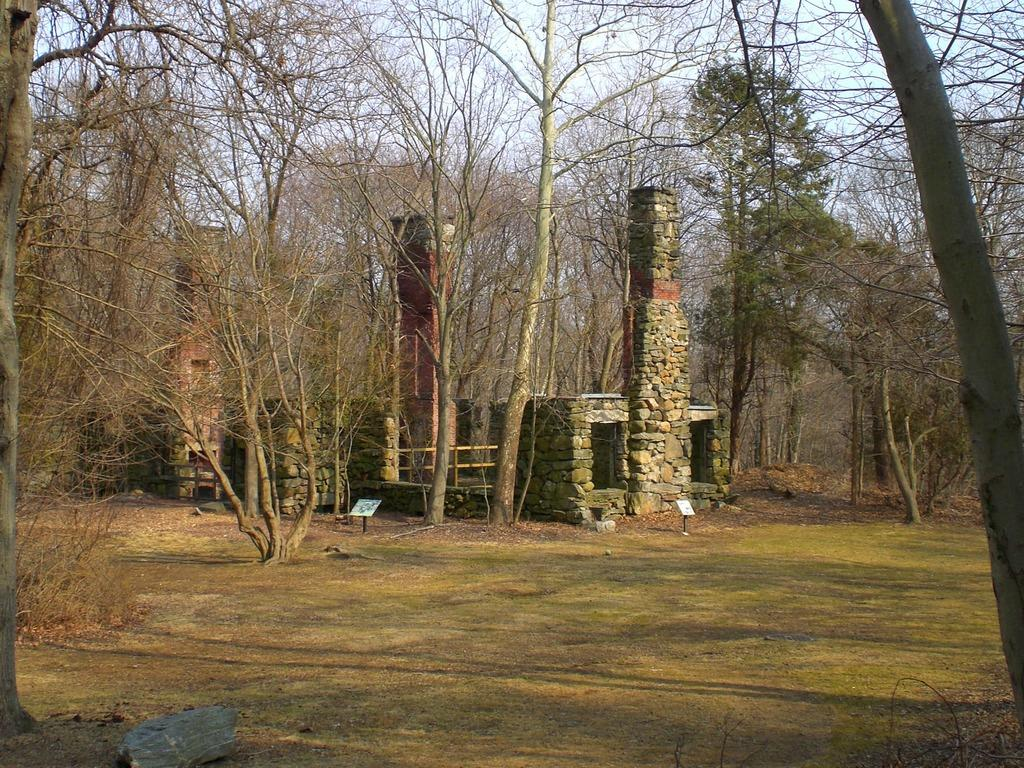What type of terrain is visible in the image? There is ground visible in the image. What natural elements can be seen on the ground? There are rocks in the image. What type of vegetation is present in the image? There are trees in the image. What is visible above the ground in the image? The sky is visible in the image. Where are the children playing in the image? There are no children present in the image. What type of station is visible in the image? There is no station present in the image. 